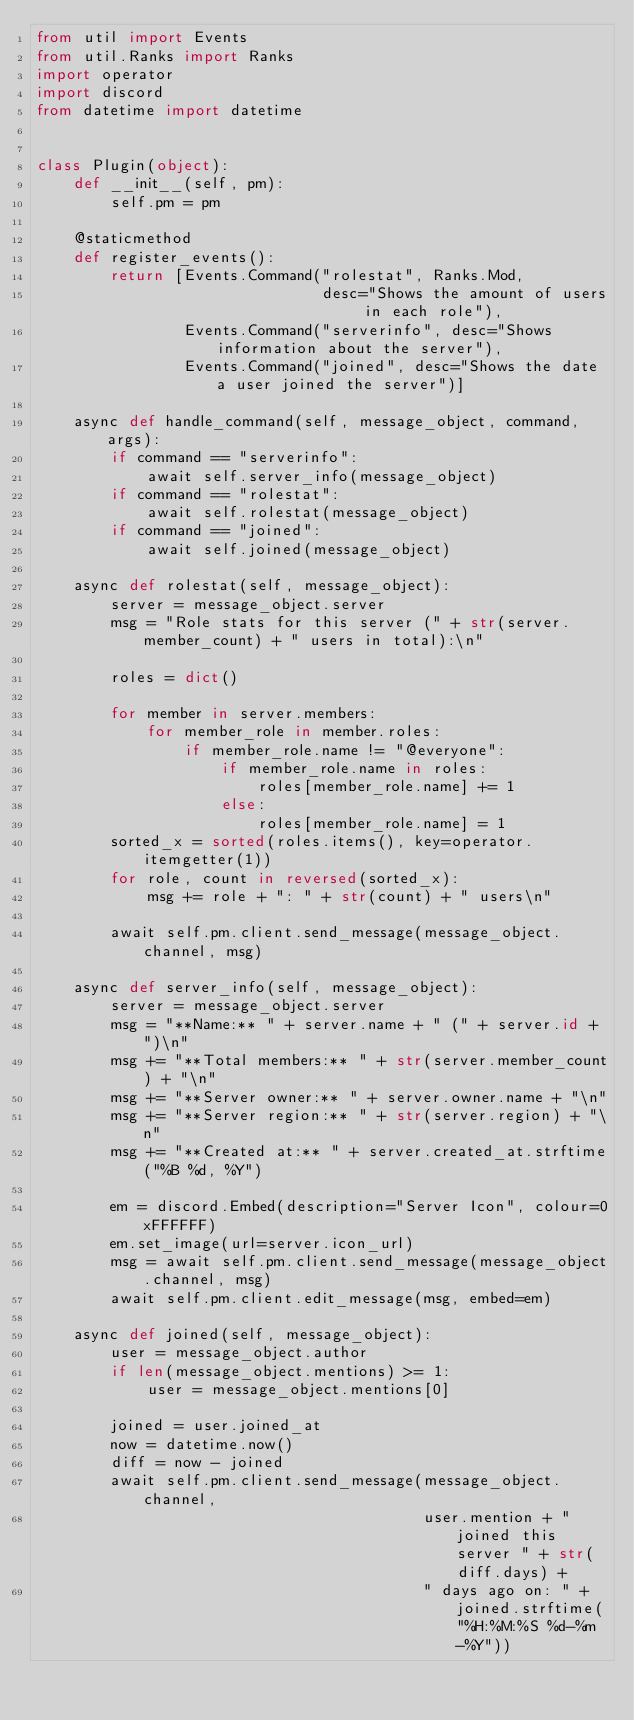Convert code to text. <code><loc_0><loc_0><loc_500><loc_500><_Python_>from util import Events
from util.Ranks import Ranks
import operator
import discord
from datetime import datetime


class Plugin(object):
    def __init__(self, pm):
        self.pm = pm

    @staticmethod
    def register_events():
        return [Events.Command("rolestat", Ranks.Mod,
                               desc="Shows the amount of users in each role"),
                Events.Command("serverinfo", desc="Shows information about the server"),
                Events.Command("joined", desc="Shows the date a user joined the server")]

    async def handle_command(self, message_object, command, args):
        if command == "serverinfo":
            await self.server_info(message_object)
        if command == "rolestat":
            await self.rolestat(message_object)
        if command == "joined":
            await self.joined(message_object)

    async def rolestat(self, message_object):
        server = message_object.server
        msg = "Role stats for this server (" + str(server.member_count) + " users in total):\n"

        roles = dict()

        for member in server.members:
            for member_role in member.roles:
                if member_role.name != "@everyone":
                    if member_role.name in roles:
                        roles[member_role.name] += 1
                    else:
                        roles[member_role.name] = 1
        sorted_x = sorted(roles.items(), key=operator.itemgetter(1))
        for role, count in reversed(sorted_x):
            msg += role + ": " + str(count) + " users\n"

        await self.pm.client.send_message(message_object.channel, msg)

    async def server_info(self, message_object):
        server = message_object.server
        msg = "**Name:** " + server.name + " (" + server.id + ")\n"
        msg += "**Total members:** " + str(server.member_count) + "\n"
        msg += "**Server owner:** " + server.owner.name + "\n"
        msg += "**Server region:** " + str(server.region) + "\n"
        msg += "**Created at:** " + server.created_at.strftime("%B %d, %Y")

        em = discord.Embed(description="Server Icon", colour=0xFFFFFF)
        em.set_image(url=server.icon_url)
        msg = await self.pm.client.send_message(message_object.channel, msg)
        await self.pm.client.edit_message(msg, embed=em)

    async def joined(self, message_object):
        user = message_object.author
        if len(message_object.mentions) >= 1:
            user = message_object.mentions[0]

        joined = user.joined_at
        now = datetime.now()
        diff = now - joined
        await self.pm.client.send_message(message_object.channel,
                                          user.mention + " joined this server " + str(diff.days) +
                                          " days ago on: " + joined.strftime("%H:%M:%S %d-%m-%Y"))
</code> 